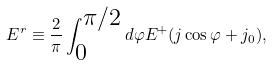<formula> <loc_0><loc_0><loc_500><loc_500>E ^ { r } \equiv \frac { 2 } { \pi } \int _ { \substack { 0 } } ^ { \substack { \pi / 2 } } d \varphi E ^ { + } ( j \cos \varphi + j _ { 0 } ) ,</formula> 